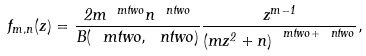<formula> <loc_0><loc_0><loc_500><loc_500>f _ { m , n } ( z ) = \frac { 2 m ^ { \ m t w o } n ^ { \ n t w o } } { B ( \ m t w o , \ n t w o ) } \frac { z ^ { m - 1 } } { \left ( m z ^ { 2 } + n \right ) ^ { \ m t w o + \ n t w o } } ,</formula> 